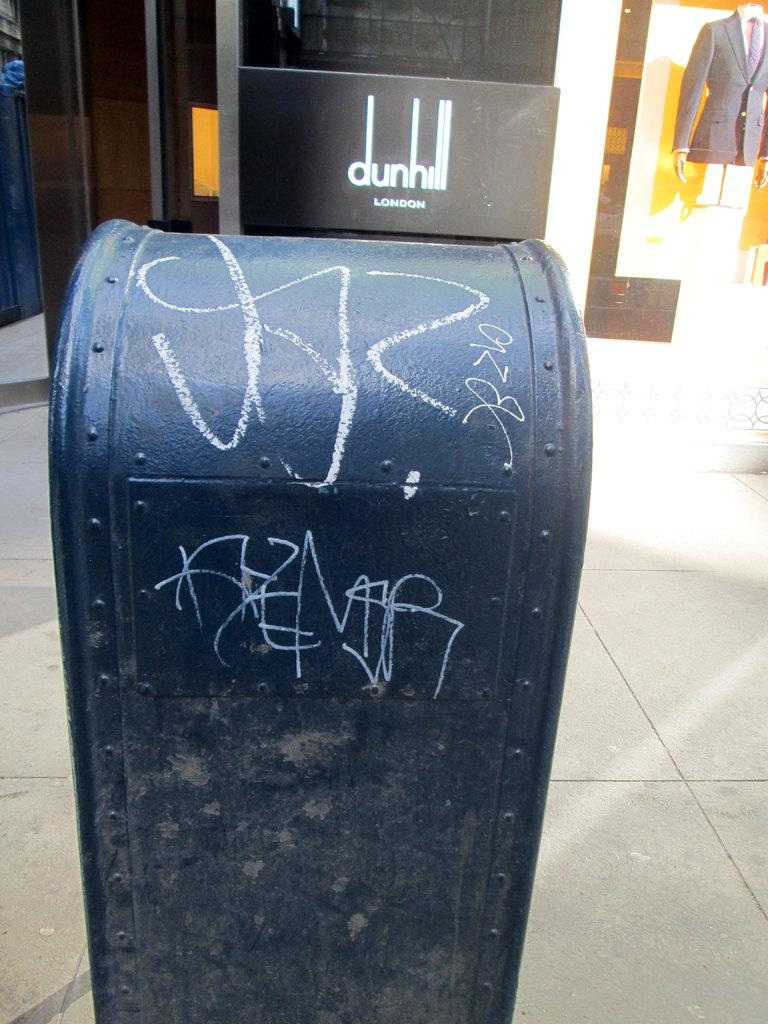Provide a one-sentence caption for the provided image. The Dunhill London logo is next to some nasty graffiti. 